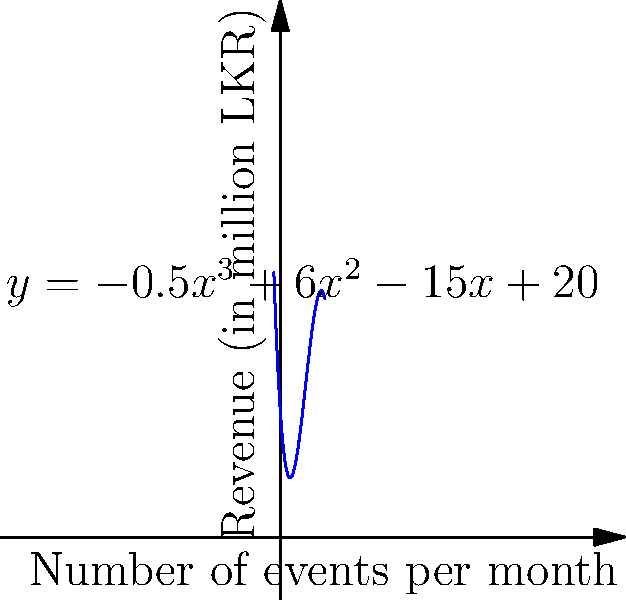A wrestling promotion company in Sri Lanka has modeled its monthly revenue (in million LKR) based on the number of events held per month. The revenue function is given by $f(x) = -0.5x^3 + 6x^2 - 15x + 20$, where $x$ is the number of events per month. What is the maximum revenue the company can achieve, and how many events should they hold to reach this maximum? To find the maximum revenue, we need to follow these steps:

1) Find the derivative of the revenue function:
   $f'(x) = -1.5x^2 + 12x - 15$

2) Set the derivative to zero to find critical points:
   $-1.5x^2 + 12x - 15 = 0$

3) Solve the quadratic equation:
   $-1.5(x^2 - 8x + 10) = 0$
   $x^2 - 8x + 10 = 0$
   $(x - 2)(x - 6) = 0$
   $x = 2$ or $x = 6$

4) Check the second derivative to confirm maximum:
   $f''(x) = -3x + 12$
   At $x = 2$: $f''(2) = 6 > 0$ (local minimum)
   At $x = 6$: $f''(6) = -6 < 0$ (local maximum)

5) Calculate the revenue at $x = 6$:
   $f(6) = -0.5(6^3) + 6(6^2) - 15(6) + 20$
   $= -108 + 216 - 90 + 20$
   $= 38$

Therefore, the maximum revenue is 38 million LKR, achieved by holding 6 events per month.
Answer: 38 million LKR; 6 events 